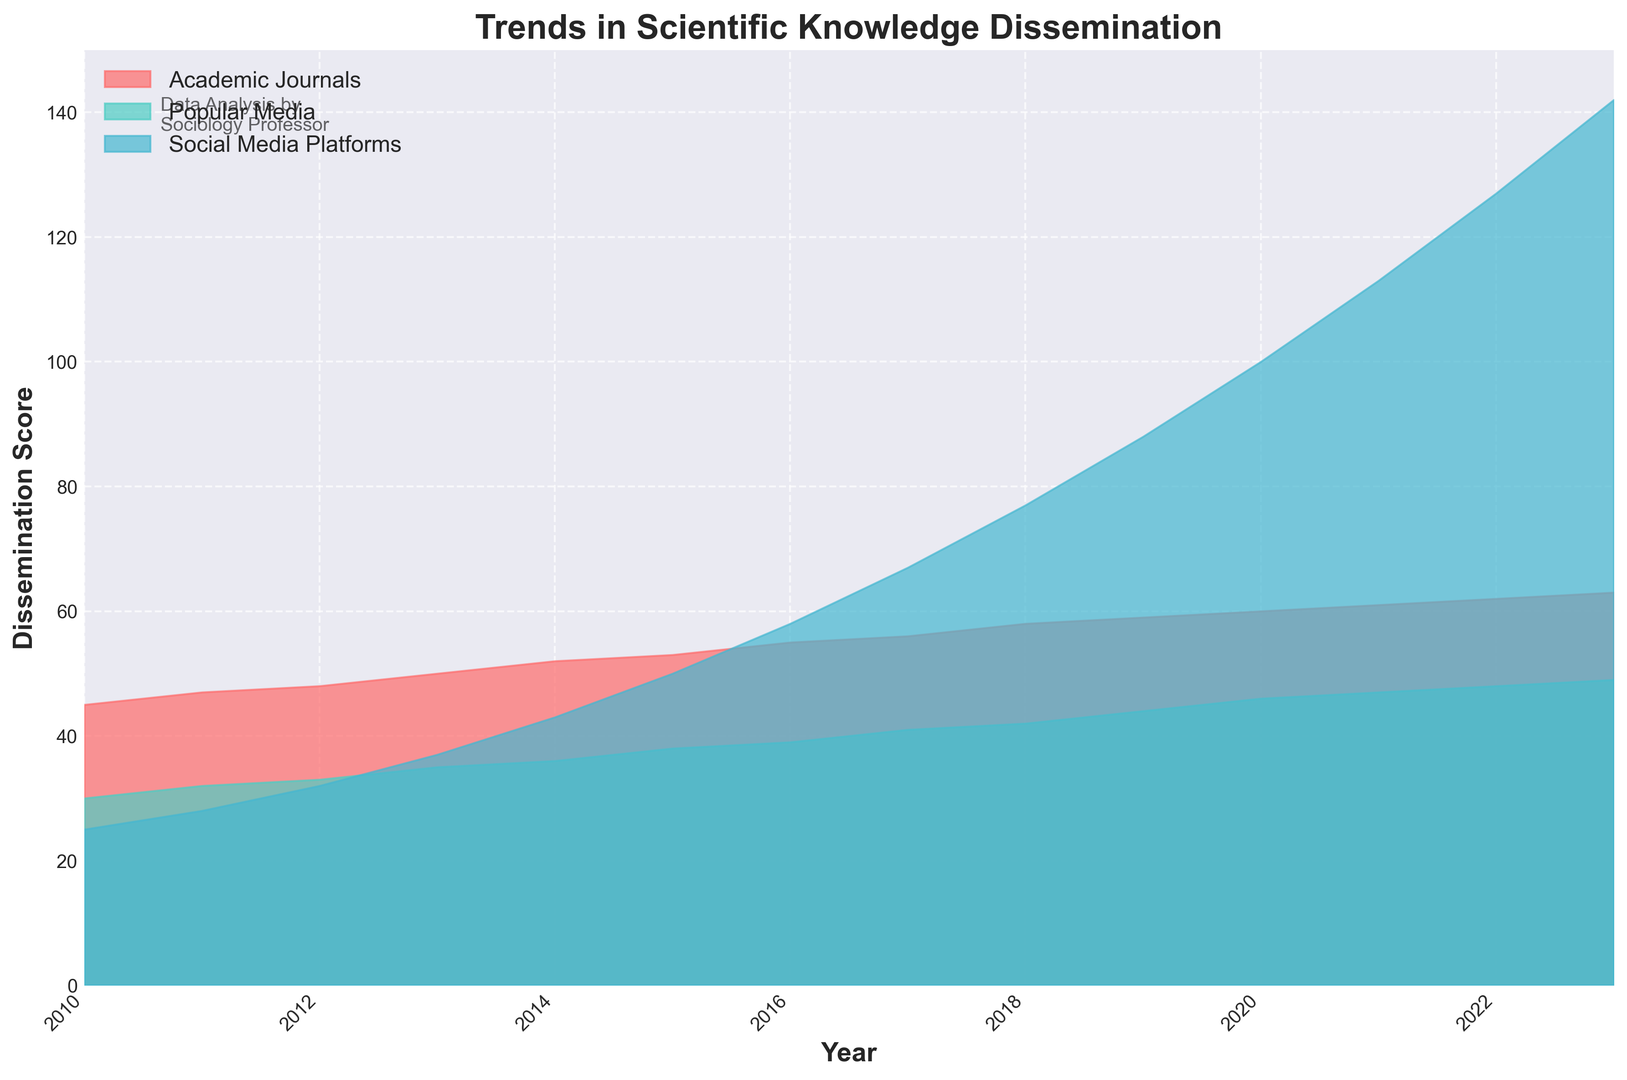What is the trend for the dissemination of scientific knowledge through social media platforms from 2010 to 2023? By observing the height of the blue area, we notice a clear upward trend, indicating that dissemination through social media platforms has significantly increased from 25 in 2010 to 142 in 2023.
Answer: The trend is increasing Which dissemination method had the highest increase over the period 2010 to 2023? Calculate the difference between the values for 2023 and 2010 for each source. Social Media Platforms increased by 142 - 25 = 117, Popular Media by 49 - 30 = 19, and Academic Journals by 63 - 45 = 18. Thus, Social Media Platforms had the highest increase.
Answer: Social Media Platforms In which year did social media platforms surpass popular media in dissemination of scientific knowledge? By looking at the blue and green areas, notice where the vertical height of the blue area starts to exceed that of the green area. This occurs around 2013, when Social Media Platforms (37) surpass Popular Media (35).
Answer: 2013 What happens to the dissemination of scientific knowledge through academic journals from 2010 to 2023? Observe the entire red area, which shows a slow, steady increase from 45 to 63 over the period.
Answer: Slow, steady increase In what year did social media platforms surpass the 100-score mark in dissemination? Look at the point on the blue area where it first exceeds the horizontal line at 100. This occurs in 2020.
Answer: 2020 Which dissemination method was second in 2015, and by how much did it differ from the first and third methods? In 2015: Academic Journals scored 53, Popular Media 38, and Social Media Platforms 50. Hence, the order is Academic Journals, Social Media Platforms, and Popular Media. The difference between first (Academic Journals) and second (Social Media Platforms) is 53 - 50 = 3, and between second and third (Popular Media) is 50 - 38 = 12.
Answer: Second: Social Media Platforms; Difference with first: 3; Difference with third: 12 How did the dissemination through popular media compare to academic journals and social media platforms in 2023? In 2023: Popular Media scored 49, while Academic Journals scored 63 and Social Media Platforms scored 142. Popular Media’s dissemination is significantly lower compared to both Academic Journals and Social Media Platforms.
Answer: Lower What is the average dissemination score for academic journals over the period 2010 to 2023? Sum all scores for academic journals from 2010 to 2023 and divide by the number of years (14). Sum = 45 + 47 + 48 + 50 + 52 + 53 + 55 + 56 + 58 + 59 + 60 + 61 + 62 + 63 = 719. Average = 719 / 14 = 51.36
Answer: 51.36 